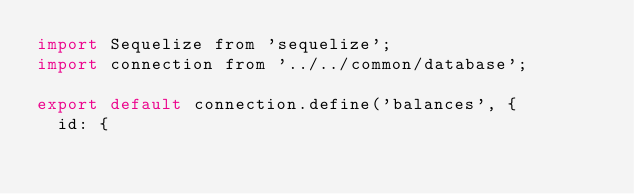Convert code to text. <code><loc_0><loc_0><loc_500><loc_500><_JavaScript_>import Sequelize from 'sequelize';
import connection from '../../common/database';

export default connection.define('balances', {
  id: {</code> 